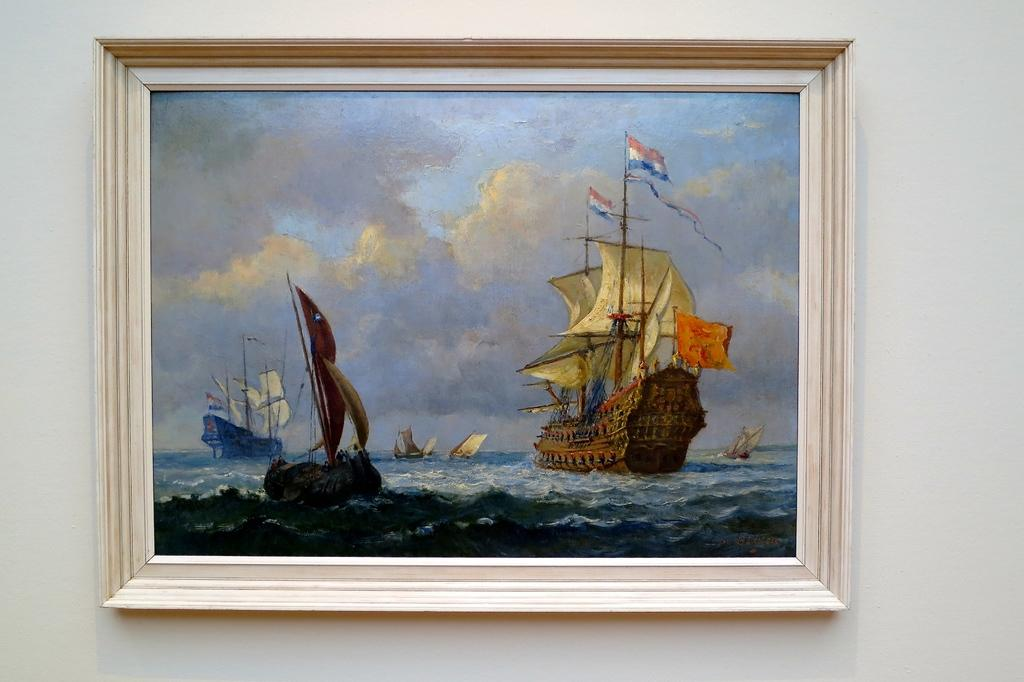What is the main subject of the painting in the image? The painting contains a painting of triremes. What is the setting of the painting? The painting depicts water. What is the weather condition in the painting? The painting includes a cloudy sky. Where is the painting located in the image? The painting is attached to a wall. How does the tank control the flow of water in the image? There is no tank present in the image, and therefore no control over the flow of water can be observed. 